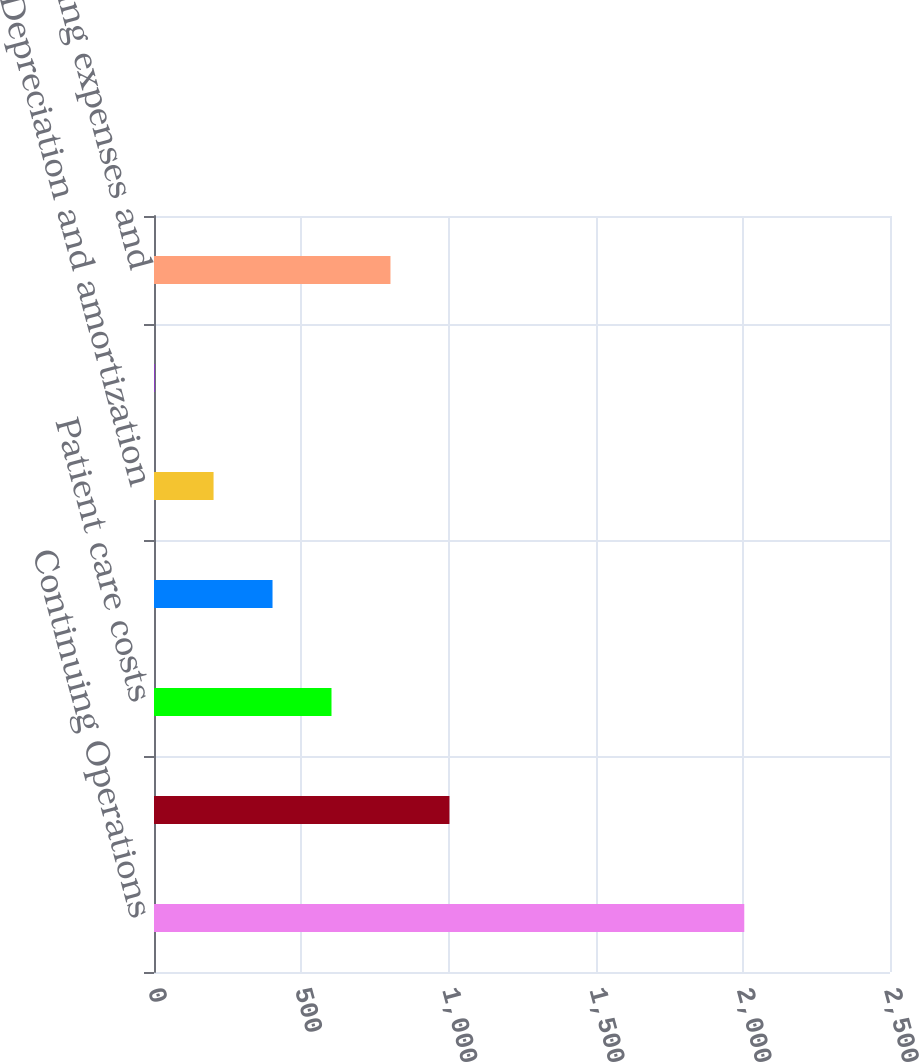Convert chart to OTSL. <chart><loc_0><loc_0><loc_500><loc_500><bar_chart><fcel>Continuing Operations<fcel>Current period services<fcel>Patient care costs<fcel>General and administrative<fcel>Depreciation and amortization<fcel>Provision for uncollectible<fcel>Total operating expenses and<nl><fcel>2005<fcel>1003.5<fcel>602.9<fcel>402.6<fcel>202.3<fcel>2<fcel>803.2<nl></chart> 